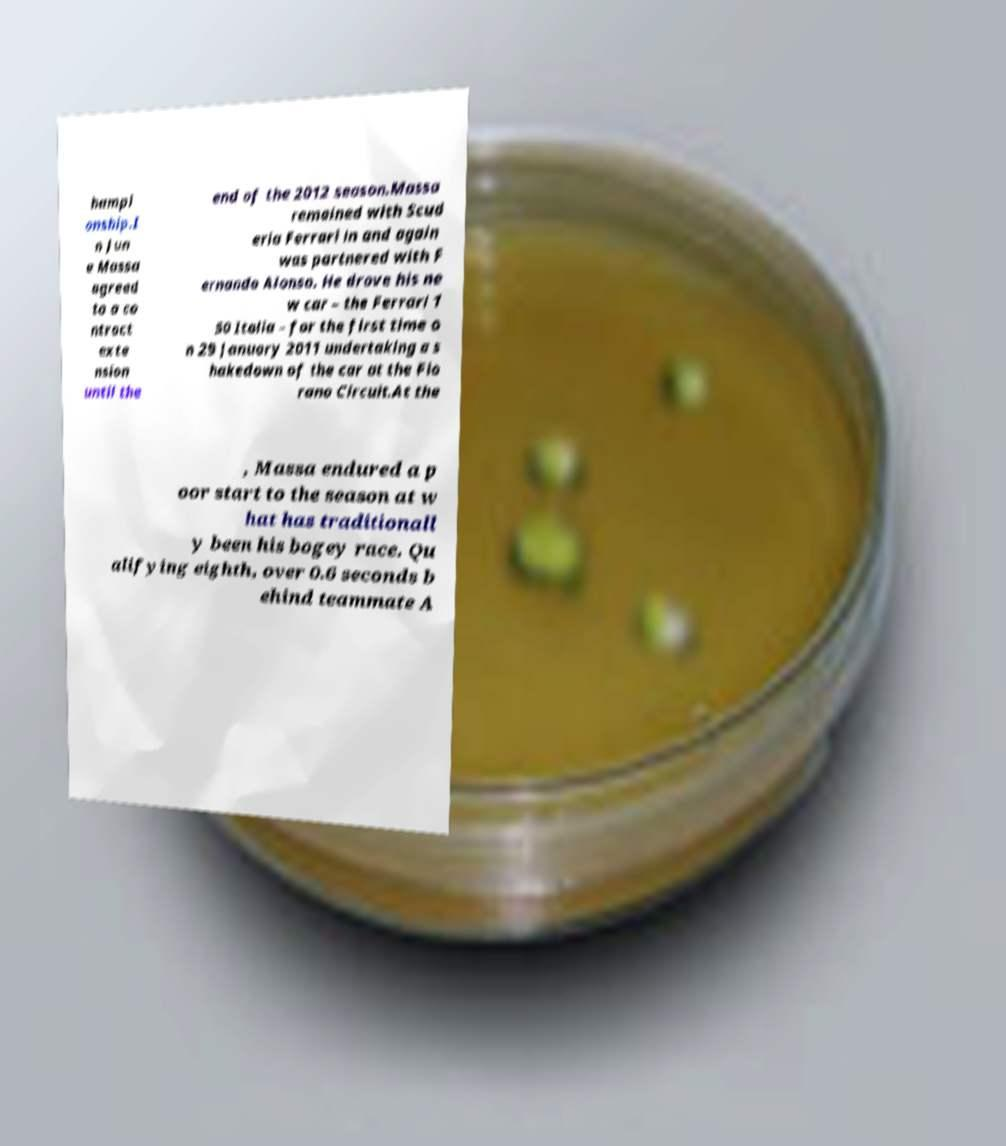There's text embedded in this image that I need extracted. Can you transcribe it verbatim? hampi onship.I n Jun e Massa agreed to a co ntract exte nsion until the end of the 2012 season.Massa remained with Scud eria Ferrari in and again was partnered with F ernando Alonso. He drove his ne w car – the Ferrari 1 50 Italia – for the first time o n 29 January 2011 undertaking a s hakedown of the car at the Fio rano Circuit.At the , Massa endured a p oor start to the season at w hat has traditionall y been his bogey race. Qu alifying eighth, over 0.6 seconds b ehind teammate A 